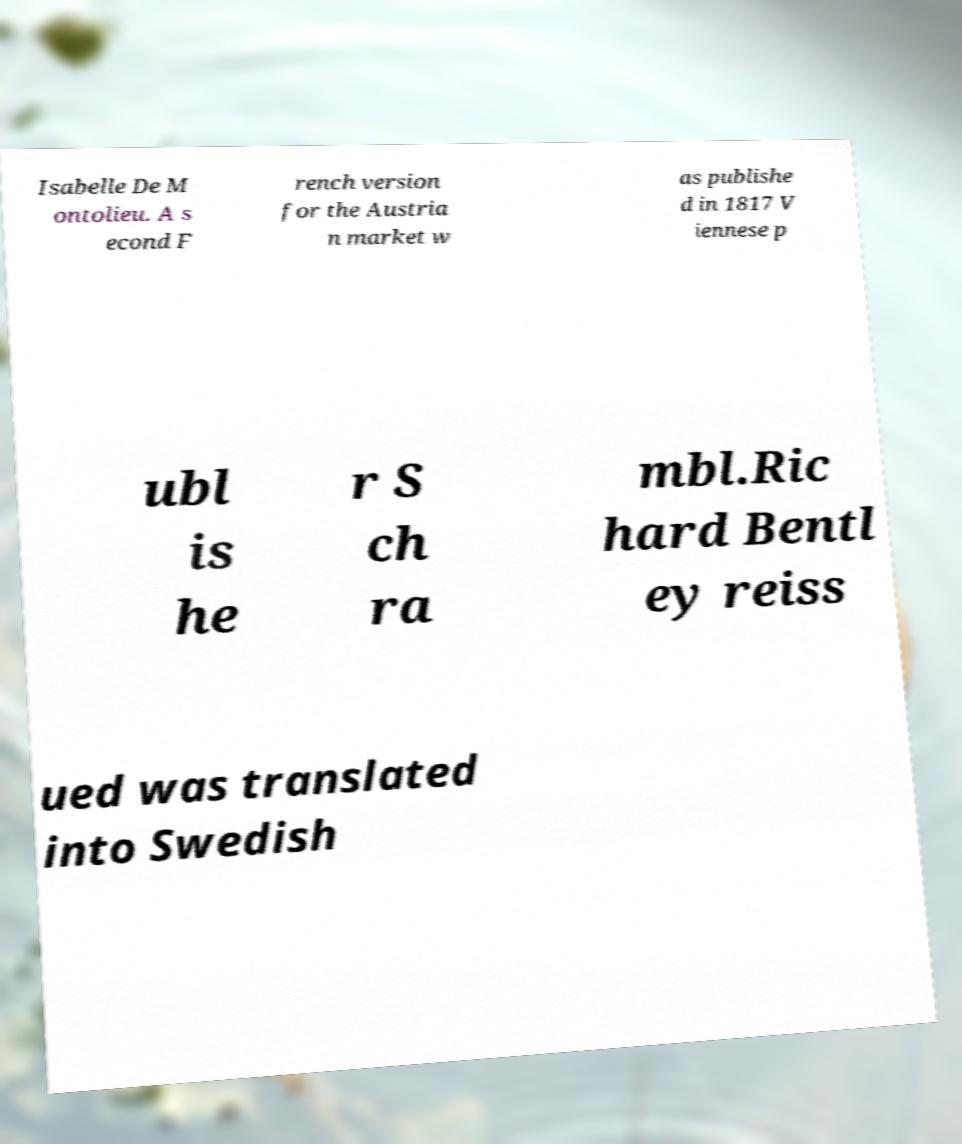For documentation purposes, I need the text within this image transcribed. Could you provide that? Isabelle De M ontolieu. A s econd F rench version for the Austria n market w as publishe d in 1817 V iennese p ubl is he r S ch ra mbl.Ric hard Bentl ey reiss ued was translated into Swedish 